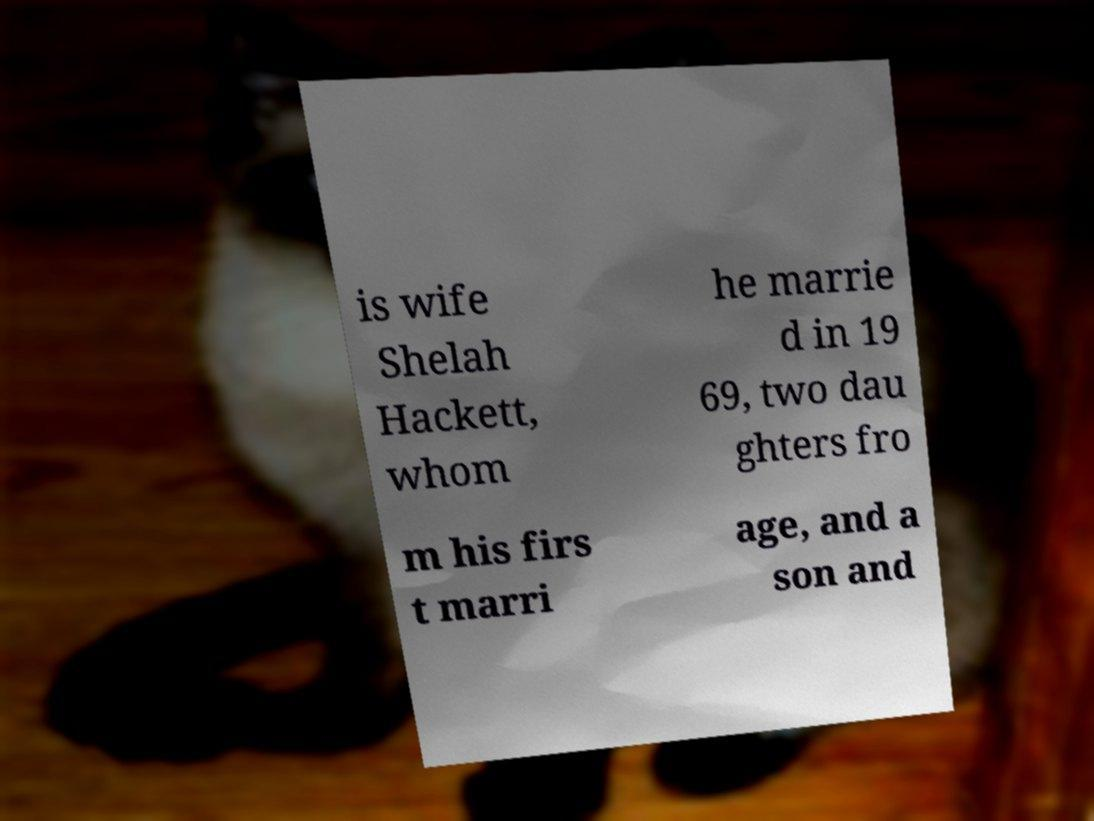For documentation purposes, I need the text within this image transcribed. Could you provide that? is wife Shelah Hackett, whom he marrie d in 19 69, two dau ghters fro m his firs t marri age, and a son and 